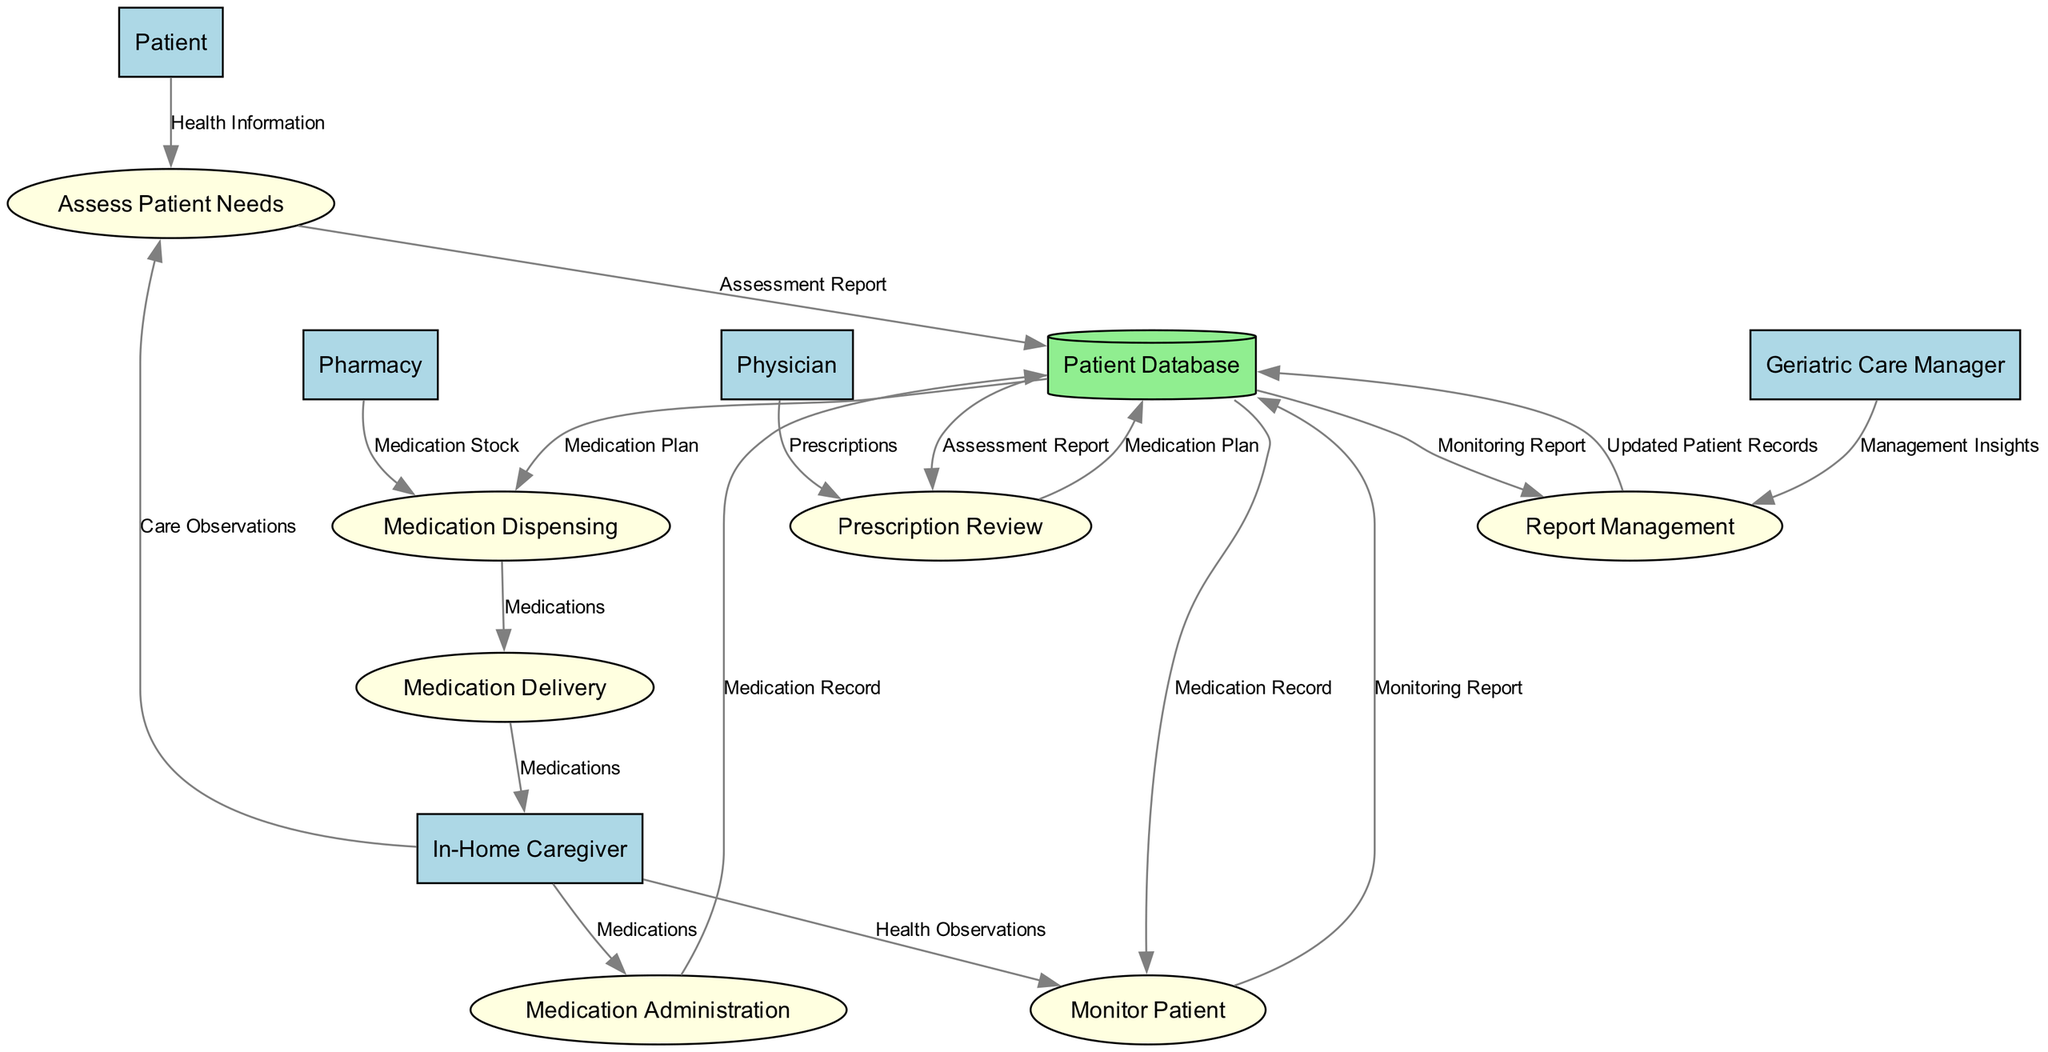What is the first process in the diagram? The diagram begins with the process labeled "Assess Patient Needs," which is where the initial evaluation of the patient's health status occurs. This is the first step in the medication management and delivery system.
Answer: Assess Patient Needs Who inputs health information into the system? The diagram indicates that the "Patient" provides health information, which is then utilized in the "Assess Patient Needs" process. This highlights the patient's role in informing their care.
Answer: Patient What type of entity is "Pharmacy"? In the diagram, "Pharmacy" is categorized as an entity responsible for dispensing medications. It directly interacts with the processes regarding medication dispensing and delivery.
Answer: Entity How many data stores are present in the diagram? The diagram contains only one data store, labeled "Patient Database," which serves as a central repository for storing patient data and records.
Answer: One What is the output of the "Monitor Patient" process? The "Monitor Patient" process outputs a "Monitoring Report," which is a record of the patient's health and response to medications, signifying the effectiveness of the treatment plan.
Answer: Monitoring Report What process occurs after "Medication Dispensing"? According to the flow of the diagram, the process that directly follows "Medication Dispensing" is "Medication Delivery." This shows the sequence involved in getting medications to the patient.
Answer: Medication Delivery Which professional is responsible for prescribing medications? The "Physician" is the professional indicated in the diagram as responsible for providing medication prescriptions, demonstrating their role in the patient's treatment plan.
Answer: Physician What data flows into the "Report Management" process? Two sources provide data to "Report Management": the "Monitoring Report" from the "Monitor Patient" process and "Management Insights" from the "Geriatric Care Manager." Both are crucial for updating patient records.
Answer: Monitoring Report, Management Insights What is the last process in the diagram? The final process outlined in the diagram is "Report Management," which is vital for updating patient records based on ongoing assessments and insights gained during the patient's care.
Answer: Report Management 